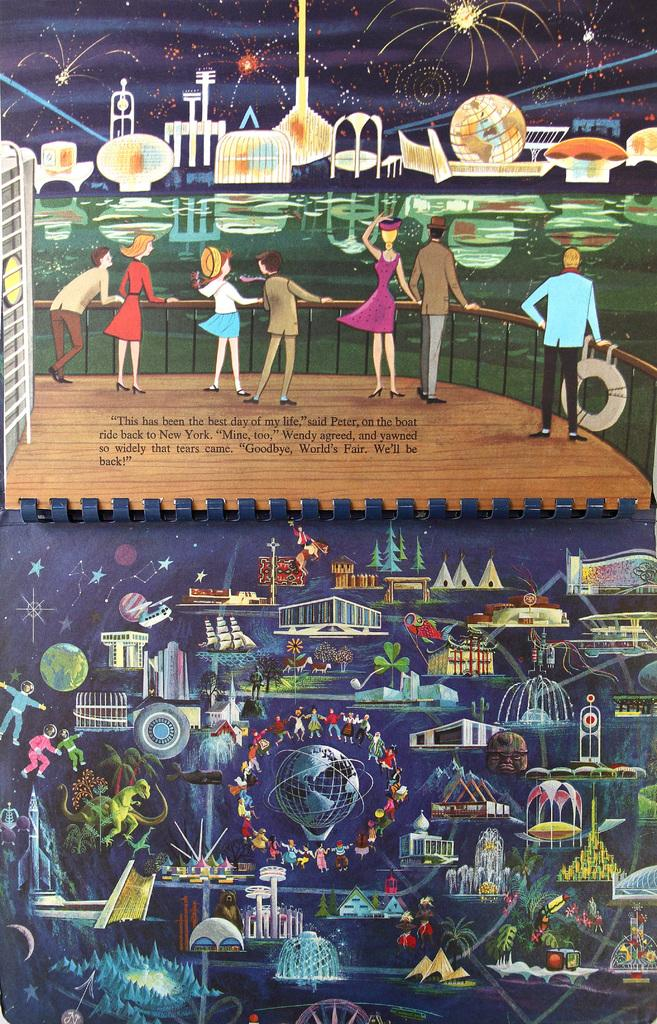<image>
Create a compact narrative representing the image presented. A page of a book where peter and wendy agree that this has been the best day of their life. 